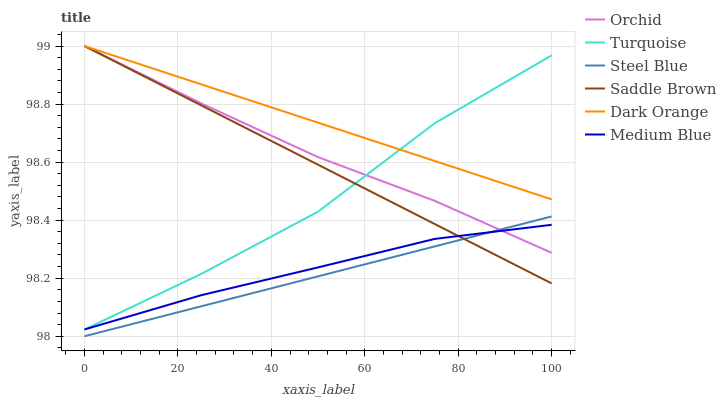Does Turquoise have the minimum area under the curve?
Answer yes or no. No. Does Turquoise have the maximum area under the curve?
Answer yes or no. No. Is Medium Blue the smoothest?
Answer yes or no. No. Is Medium Blue the roughest?
Answer yes or no. No. Does Turquoise have the lowest value?
Answer yes or no. No. Does Turquoise have the highest value?
Answer yes or no. No. Is Steel Blue less than Dark Orange?
Answer yes or no. Yes. Is Turquoise greater than Steel Blue?
Answer yes or no. Yes. Does Steel Blue intersect Dark Orange?
Answer yes or no. No. 